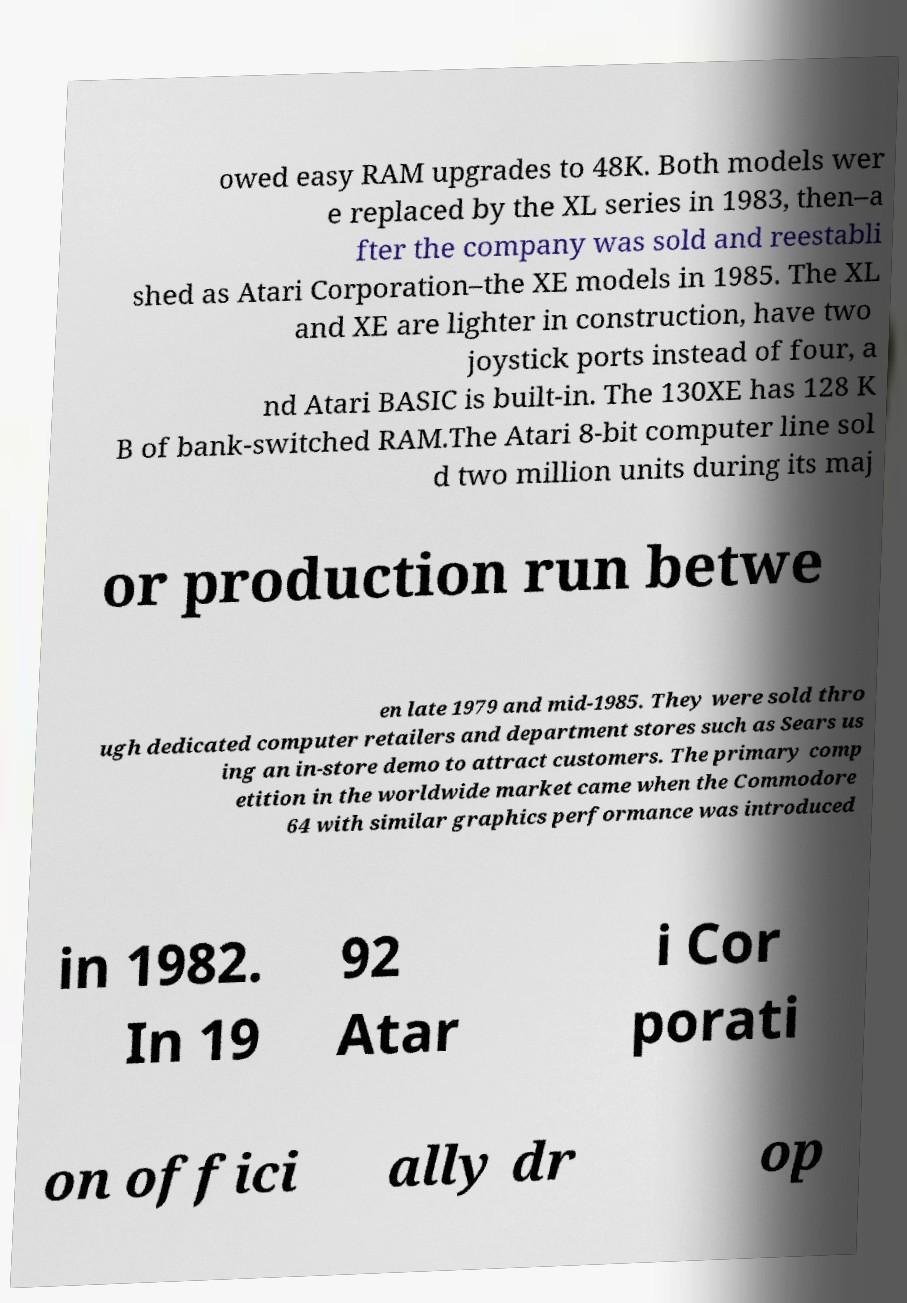I need the written content from this picture converted into text. Can you do that? owed easy RAM upgrades to 48K. Both models wer e replaced by the XL series in 1983, then–a fter the company was sold and reestabli shed as Atari Corporation–the XE models in 1985. The XL and XE are lighter in construction, have two joystick ports instead of four, a nd Atari BASIC is built-in. The 130XE has 128 K B of bank-switched RAM.The Atari 8-bit computer line sol d two million units during its maj or production run betwe en late 1979 and mid-1985. They were sold thro ugh dedicated computer retailers and department stores such as Sears us ing an in-store demo to attract customers. The primary comp etition in the worldwide market came when the Commodore 64 with similar graphics performance was introduced in 1982. In 19 92 Atar i Cor porati on offici ally dr op 